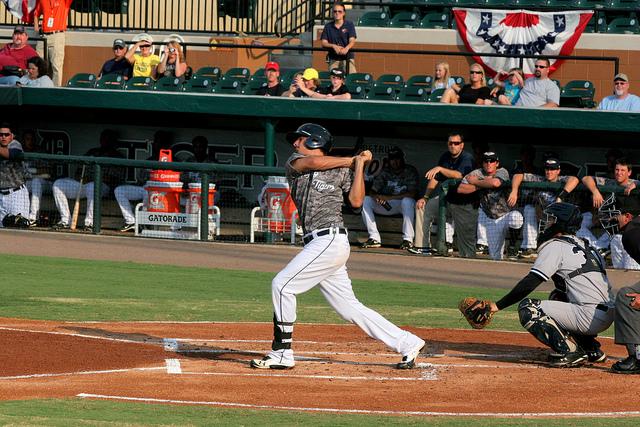Are there spectators?
Write a very short answer. Yes. Is it a sunny day?
Write a very short answer. Yes. Is this a real game or practice session?
Quick response, please. Real game. Is the batter wearing a shin guard?
Keep it brief. Yes. What are the three men at the box looking at?
Answer briefly. Batter. Is it possible to count the people in this picture?
Quick response, please. Yes. Is there a large crowd?
Write a very short answer. No. Where is the Dayton Daily News ad?
Answer briefly. Nowhere. What is the baseball player wearing on his hand?
Short answer required. Glove. 